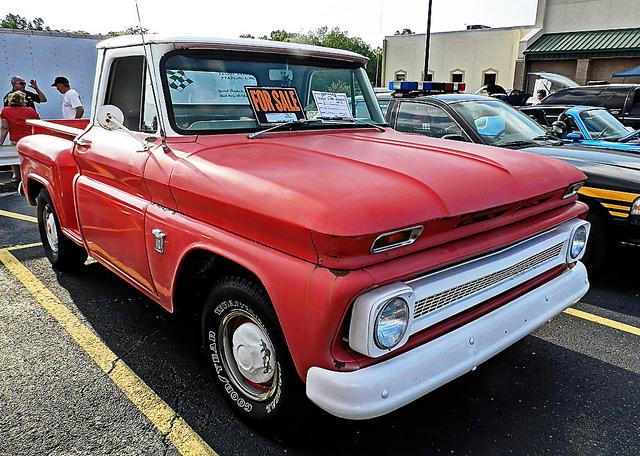How many boats are parked next to the red truck?
Answer briefly. 0. Is the red truck for sale?
Give a very brief answer. Yes. Does the red truck look new?
Be succinct. No. How many doors does the red truck have?
Answer briefly. 2. What kind of event is this?
Answer briefly. Car show. What type of vehicle is in the image?
Answer briefly. Truck. 